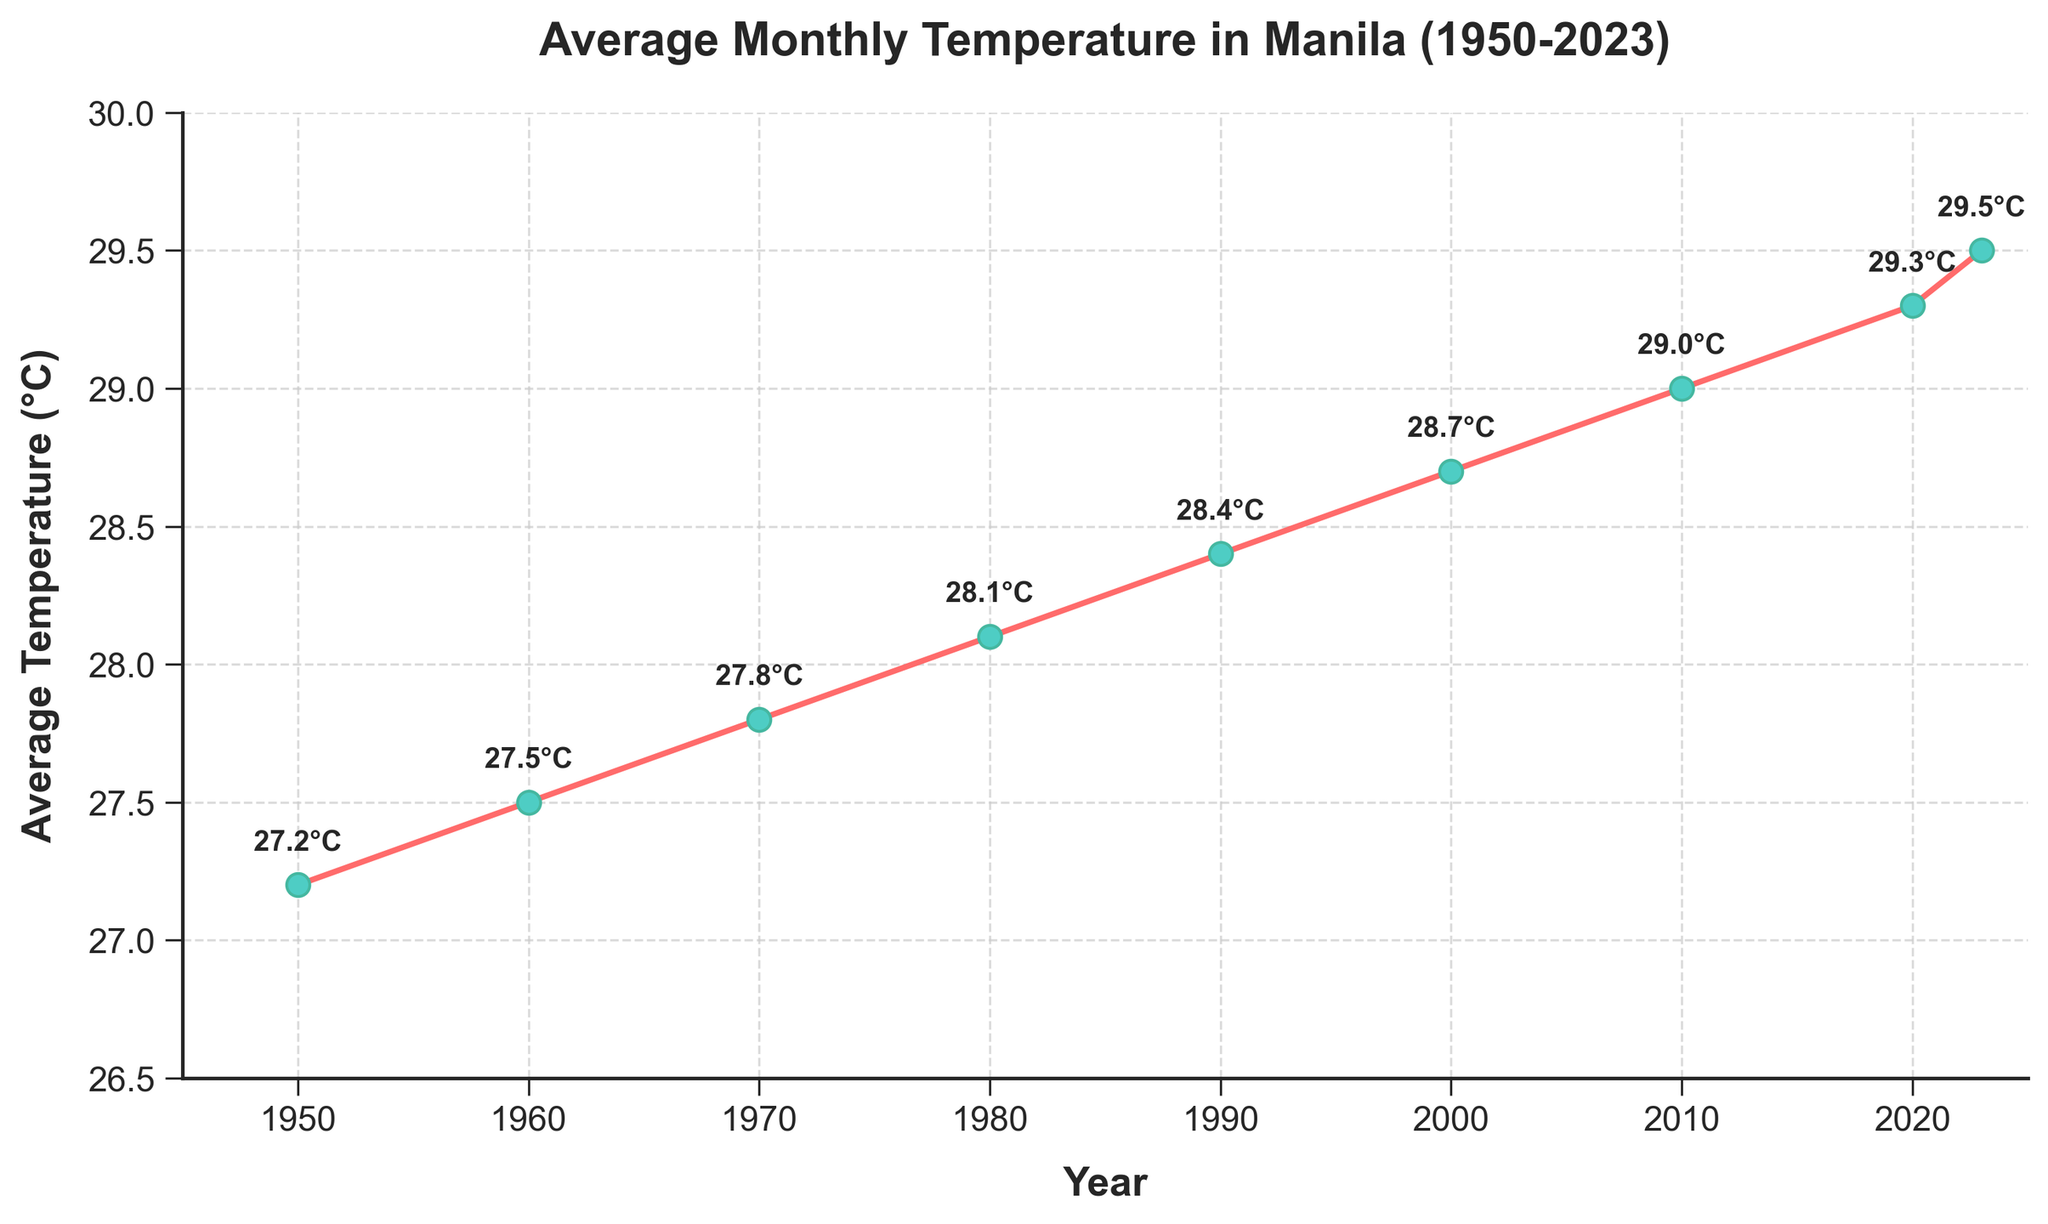What is the average temperature in Manila in 1980? Locate the point corresponding to 1980 on the x-axis and match it to the y-axis value, which shows 28.1°C.
Answer: 28.1°C How much did the average temperature increase between 1950 and 2023? The temperature in 1950 was 27.2°C and in 2023 it was 29.5°C. The difference is 29.5°C - 27.2°C = 2.3°C.
Answer: 2.3°C In which decade did the highest average temperature increase occur? Look at the differences between points for each decade: 
- 1950 to 1960: 27.5°C - 27.2°C = 0.3°C
- 1960 to 1970: 27.8°C - 27.5°C = 0.3°C
- 1970 to 1980: 28.1°C - 27.8°C = 0.3°C
- 1980 to 1990: 28.4°C - 28.1°C = 0.3°C
- 1990 to 2000: 28.7°C - 28.4°C = 0.3°C
- 2000 to 2010: 29.0°C - 28.7°C = 0.3°C
- 2010 to 2020: 29.3°C - 29.0°C = 0.3°C
- 2020 to 2023: 29.5°C - 29.3°C = 0.2°C
All decades have the same increase of 0.3°C, except for 2020 to 2023.
Answer: 1950-2010 What is the temperature difference between 2000 and 2010? The temperature in 2000 was 28.7°C, and in 2010 it was 29.0°C. The difference is 29.0°C - 28.7°C = 0.3°C.
Answer: 0.3°C In which years does the average temperature surpass 28°C? Identify points where the y-value (temperature) is greater than 28°C. These years are 1980, 1990, 2000, 2010, 2020, and 2023.
Answer: 1980, 1990, 2000, 2010, 2020, 2023 How many years are shown on the plot? Count the x-axis data points: 1950, 1960, 1970, 1980, 1990, 2000, 2010, 2020, 2023. There are 9 years represented.
Answer: 9 What was the average temperature at the start and the end of the dataset? The temperature in 1950 (start) was 27.2°C, and in 2023 (end) was 29.5°C. These are the temperatures provided at both ends of the plot.
Answer: 27.2°C, 29.5°C What's the overall trend shown in the plot? The line chart shows a general upward trend over the years from 1950 to 2023, indicating a steady increase in average monthly temperatures in Manila.
Answer: Upward trend During which year’s average temperature reached 28.4°C? Locate the point on the y-axis corresponding to 28.4°C and trace it back to the x-axis. This occurs at 1990.
Answer: 1990 